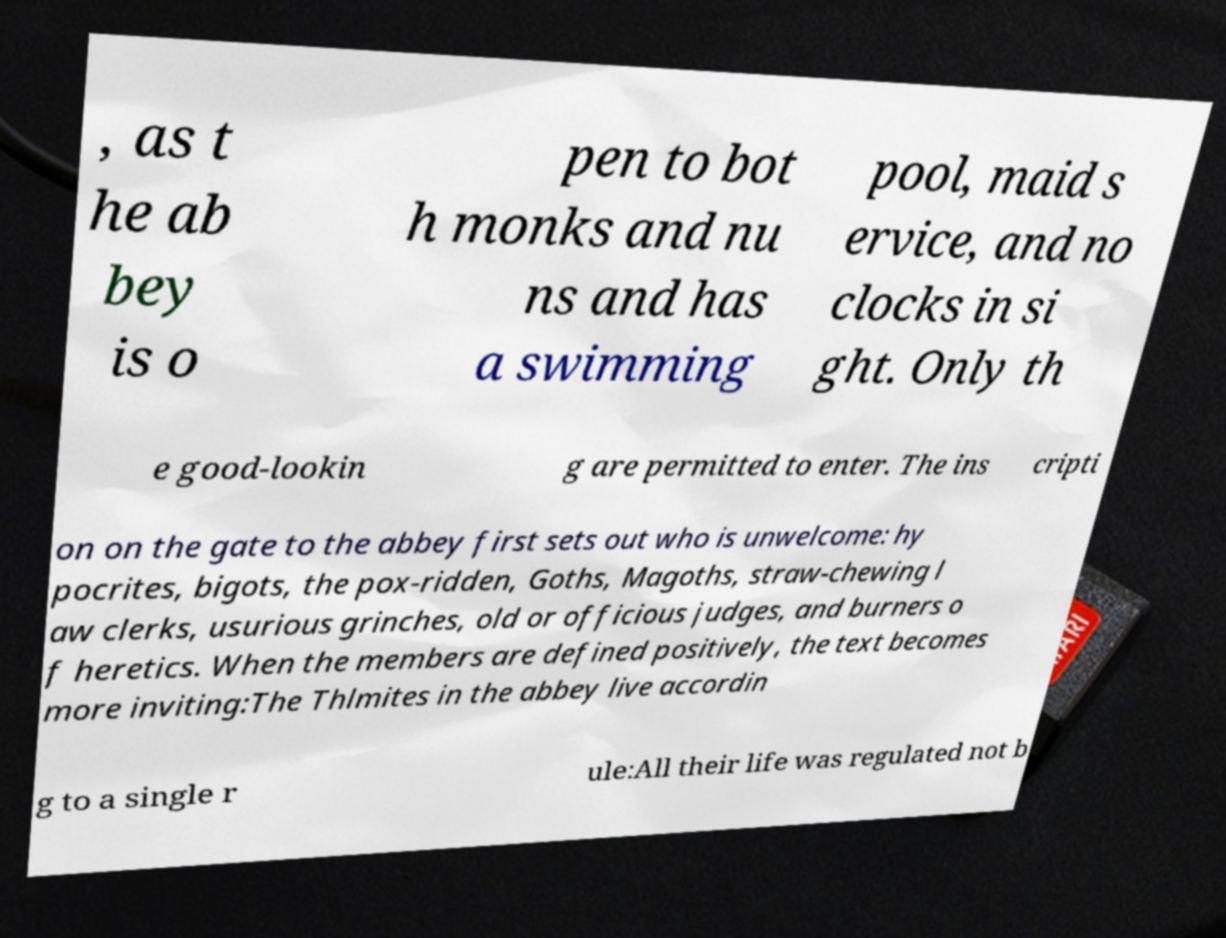What messages or text are displayed in this image? I need them in a readable, typed format. , as t he ab bey is o pen to bot h monks and nu ns and has a swimming pool, maid s ervice, and no clocks in si ght. Only th e good-lookin g are permitted to enter. The ins cripti on on the gate to the abbey first sets out who is unwelcome: hy pocrites, bigots, the pox-ridden, Goths, Magoths, straw-chewing l aw clerks, usurious grinches, old or officious judges, and burners o f heretics. When the members are defined positively, the text becomes more inviting:The Thlmites in the abbey live accordin g to a single r ule:All their life was regulated not b 